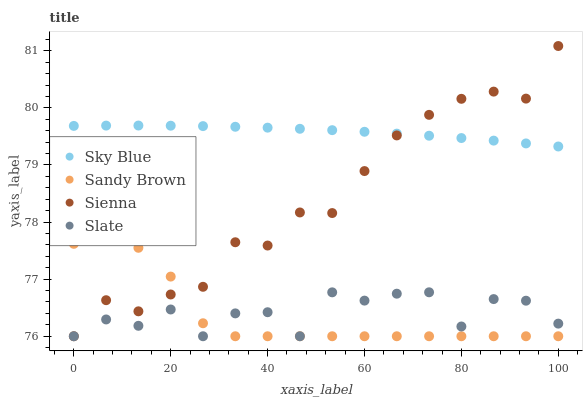Does Sandy Brown have the minimum area under the curve?
Answer yes or no. Yes. Does Sky Blue have the maximum area under the curve?
Answer yes or no. Yes. Does Slate have the minimum area under the curve?
Answer yes or no. No. Does Slate have the maximum area under the curve?
Answer yes or no. No. Is Sky Blue the smoothest?
Answer yes or no. Yes. Is Slate the roughest?
Answer yes or no. Yes. Is Slate the smoothest?
Answer yes or no. No. Is Sky Blue the roughest?
Answer yes or no. No. Does Sienna have the lowest value?
Answer yes or no. Yes. Does Sky Blue have the lowest value?
Answer yes or no. No. Does Sienna have the highest value?
Answer yes or no. Yes. Does Sky Blue have the highest value?
Answer yes or no. No. Is Slate less than Sky Blue?
Answer yes or no. Yes. Is Sky Blue greater than Sandy Brown?
Answer yes or no. Yes. Does Slate intersect Sandy Brown?
Answer yes or no. Yes. Is Slate less than Sandy Brown?
Answer yes or no. No. Is Slate greater than Sandy Brown?
Answer yes or no. No. Does Slate intersect Sky Blue?
Answer yes or no. No. 